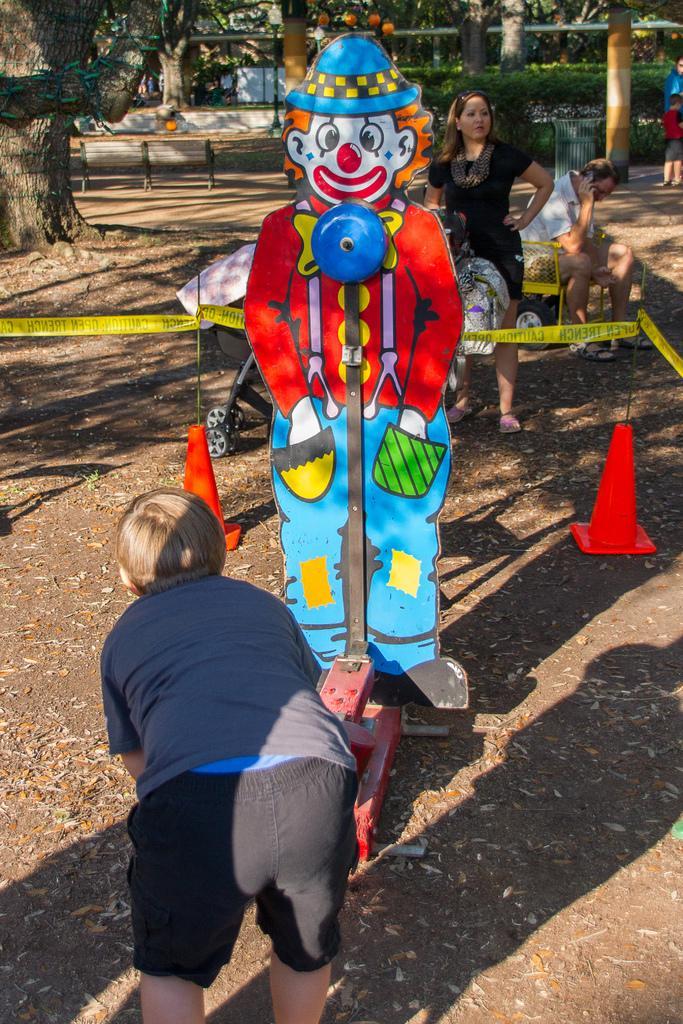Please provide a concise description of this image. In this picture we can see a boy standing in the park. Behind there is a cartoon cardboard statue. In the background we can see a woman and some trees. 